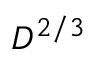<formula> <loc_0><loc_0><loc_500><loc_500>D ^ { 2 / 3 }</formula> 